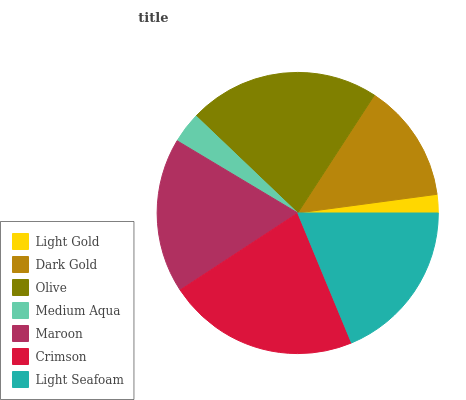Is Light Gold the minimum?
Answer yes or no. Yes. Is Olive the maximum?
Answer yes or no. Yes. Is Dark Gold the minimum?
Answer yes or no. No. Is Dark Gold the maximum?
Answer yes or no. No. Is Dark Gold greater than Light Gold?
Answer yes or no. Yes. Is Light Gold less than Dark Gold?
Answer yes or no. Yes. Is Light Gold greater than Dark Gold?
Answer yes or no. No. Is Dark Gold less than Light Gold?
Answer yes or no. No. Is Maroon the high median?
Answer yes or no. Yes. Is Maroon the low median?
Answer yes or no. Yes. Is Olive the high median?
Answer yes or no. No. Is Light Seafoam the low median?
Answer yes or no. No. 